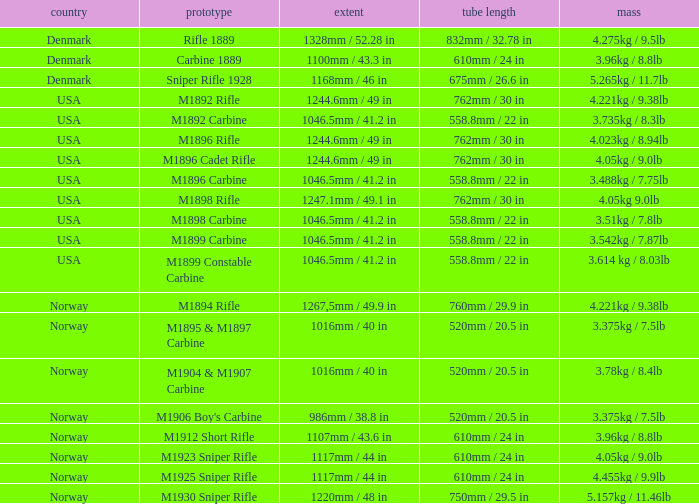What is Length, when Barrel Length is 750mm / 29.5 in? 1220mm / 48 in. 